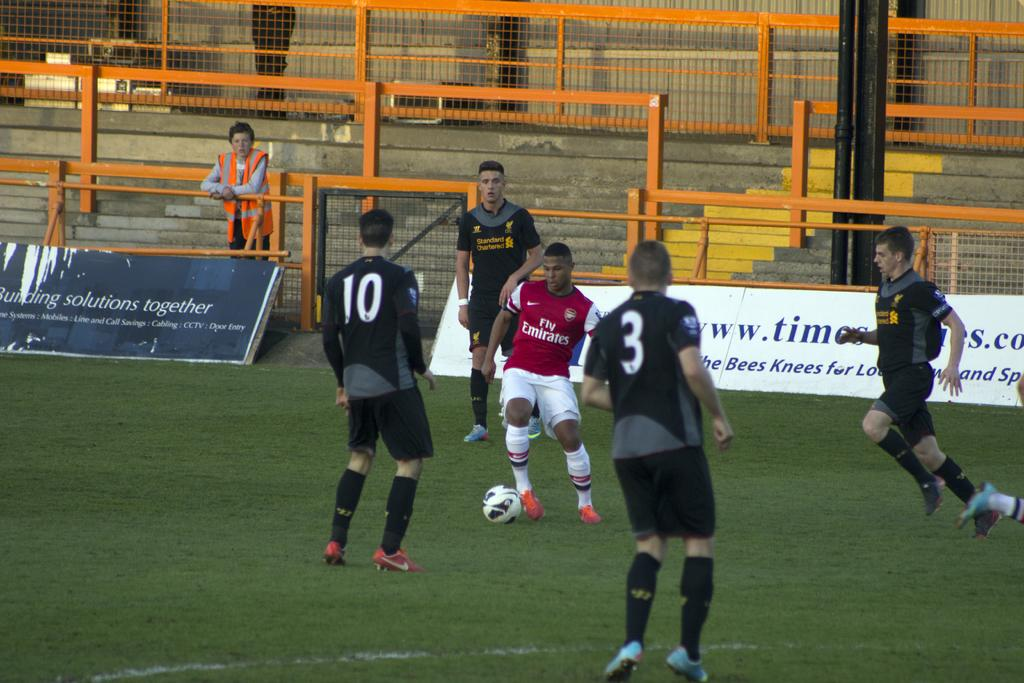<image>
Share a concise interpretation of the image provided. A player in a red jersey with the text Fly Emirates is dribbling a soccer ball. 